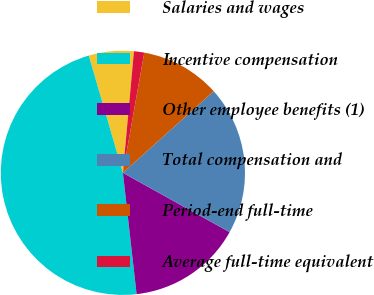Convert chart to OTSL. <chart><loc_0><loc_0><loc_500><loc_500><pie_chart><fcel>Salaries and wages<fcel>Incentive compensation<fcel>Other employee benefits (1)<fcel>Total compensation and<fcel>Period-end full-time<fcel>Average full-time equivalent<nl><fcel>5.95%<fcel>47.28%<fcel>15.14%<fcel>19.73%<fcel>10.54%<fcel>1.36%<nl></chart> 